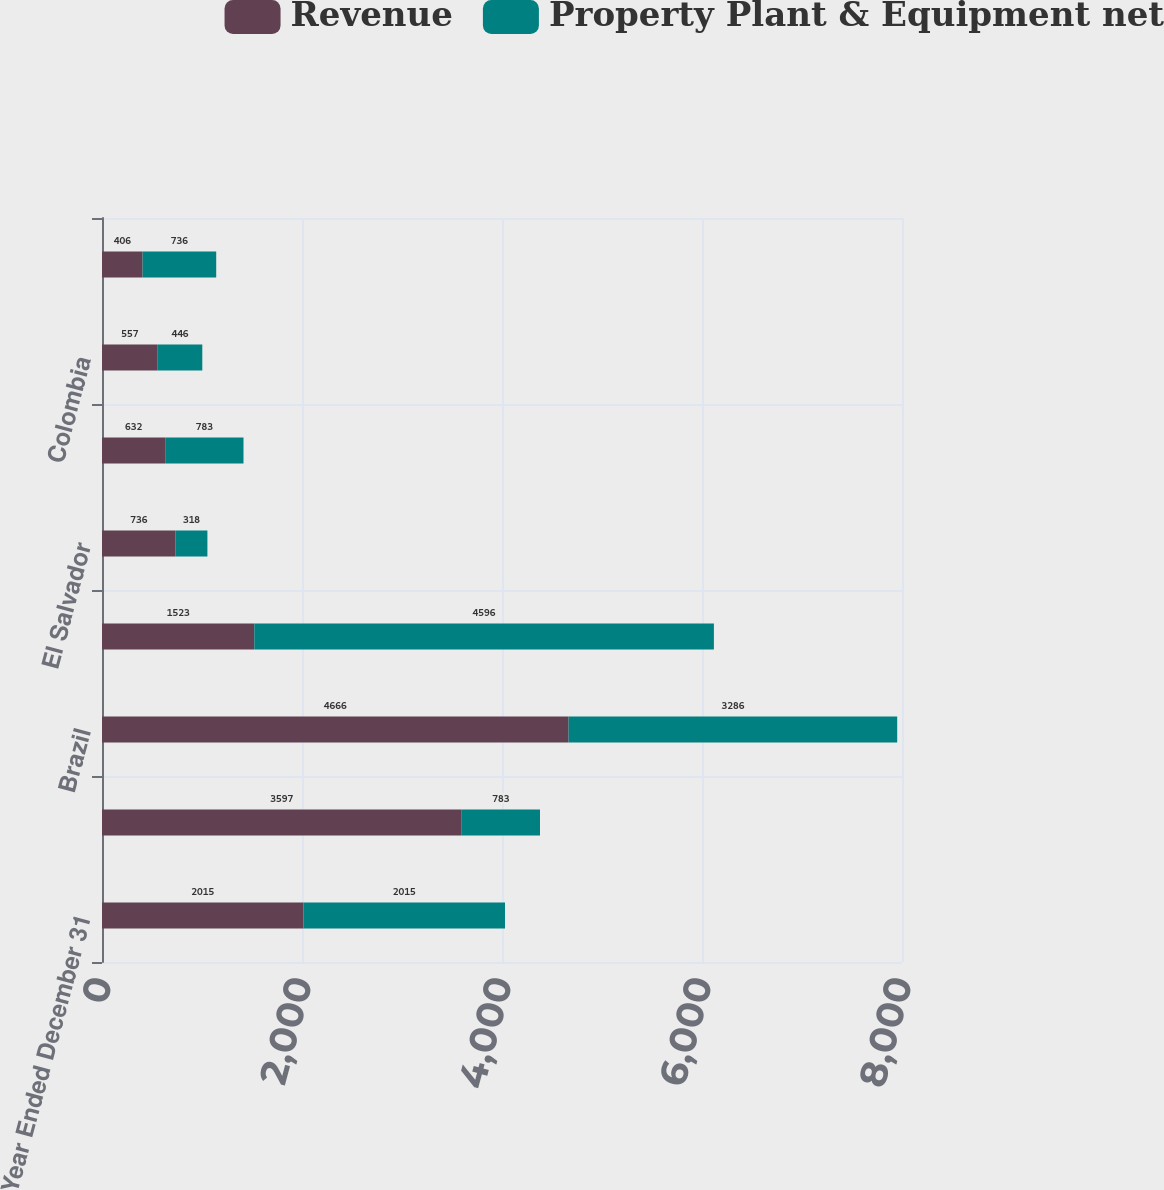Convert chart to OTSL. <chart><loc_0><loc_0><loc_500><loc_500><stacked_bar_chart><ecel><fcel>Year Ended December 31<fcel>United States (1)<fcel>Brazil<fcel>Chile<fcel>El Salvador<fcel>Dominican Republic<fcel>Colombia<fcel>Philippines<nl><fcel>Revenue<fcel>2015<fcel>3597<fcel>4666<fcel>1523<fcel>736<fcel>632<fcel>557<fcel>406<nl><fcel>Property Plant & Equipment net<fcel>2015<fcel>783<fcel>3286<fcel>4596<fcel>318<fcel>783<fcel>446<fcel>736<nl></chart> 